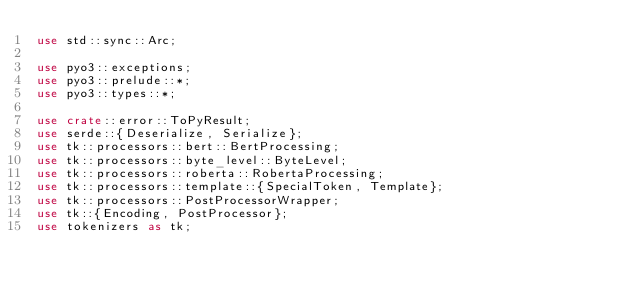<code> <loc_0><loc_0><loc_500><loc_500><_Rust_>use std::sync::Arc;

use pyo3::exceptions;
use pyo3::prelude::*;
use pyo3::types::*;

use crate::error::ToPyResult;
use serde::{Deserialize, Serialize};
use tk::processors::bert::BertProcessing;
use tk::processors::byte_level::ByteLevel;
use tk::processors::roberta::RobertaProcessing;
use tk::processors::template::{SpecialToken, Template};
use tk::processors::PostProcessorWrapper;
use tk::{Encoding, PostProcessor};
use tokenizers as tk;
</code> 